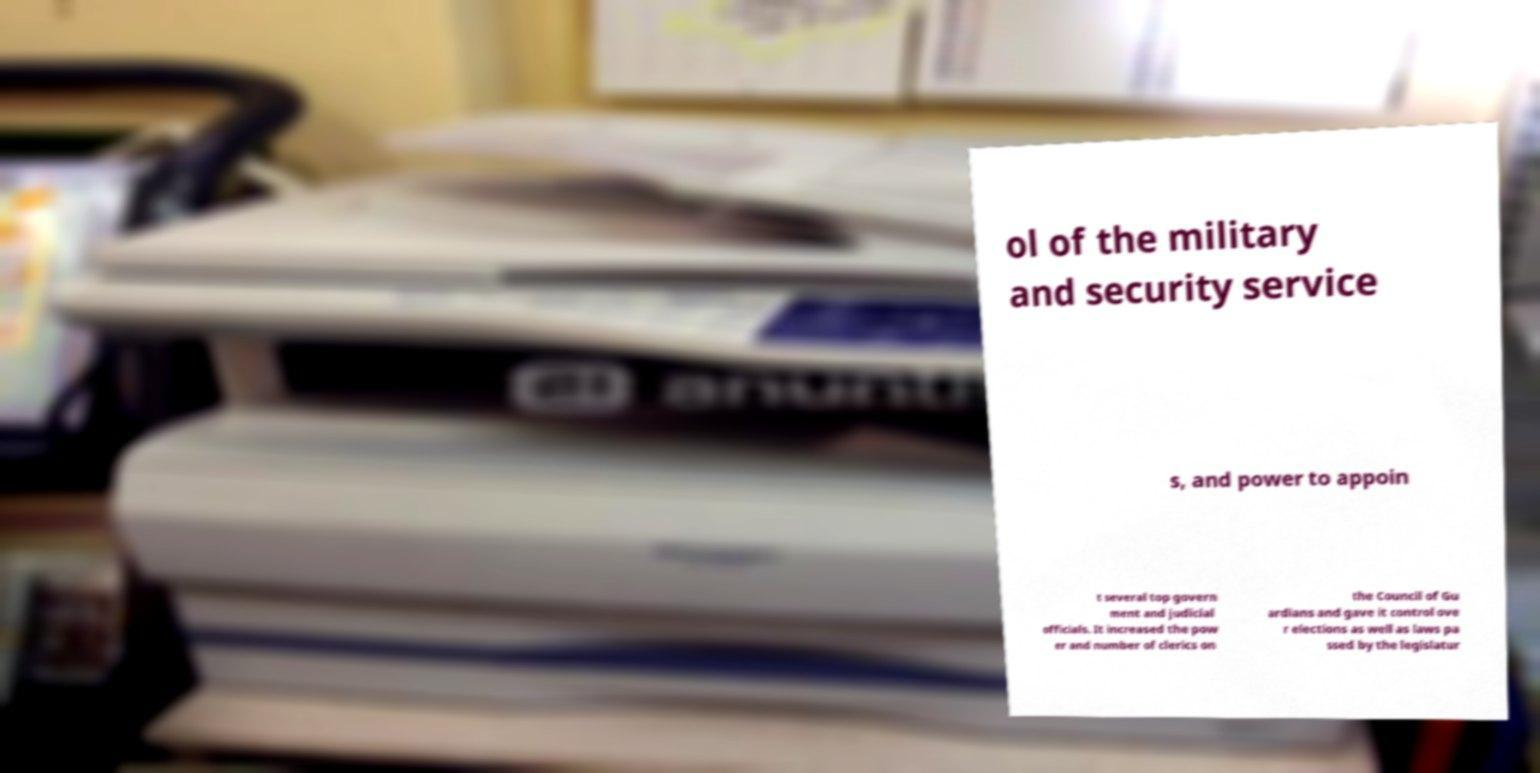Could you extract and type out the text from this image? ol of the military and security service s, and power to appoin t several top govern ment and judicial officials. It increased the pow er and number of clerics on the Council of Gu ardians and gave it control ove r elections as well as laws pa ssed by the legislatur 